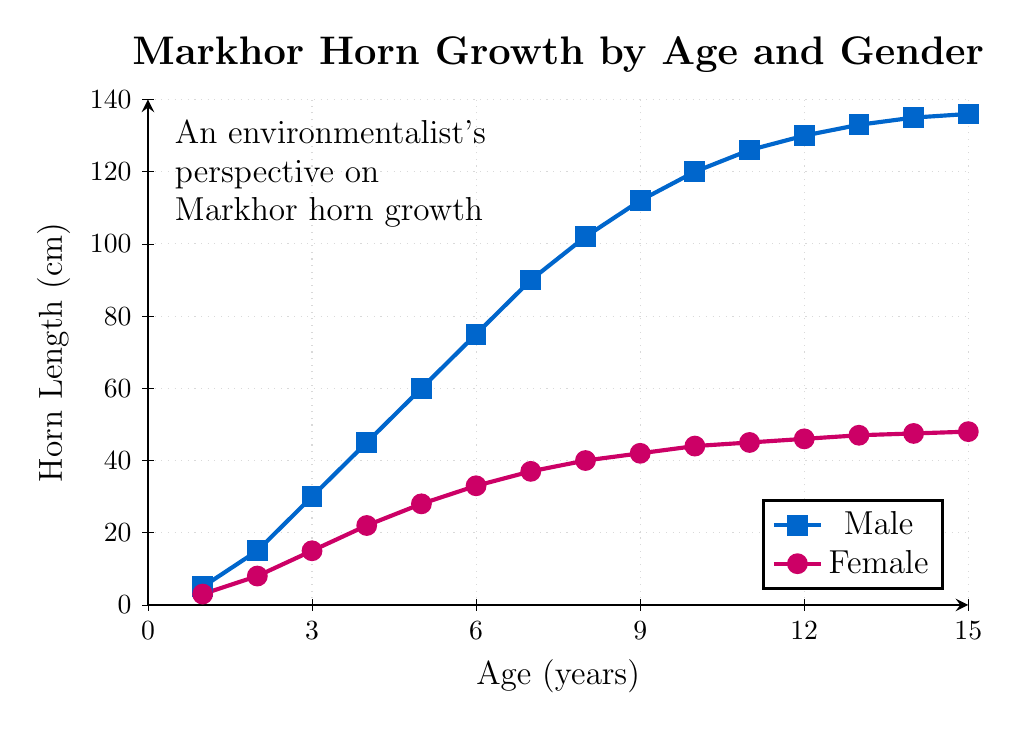What is the horn length difference between male and female Markhors at age 10? To find the difference in horn length between male and female Markhors at age 10, look at the horn lengths for both genders at that specific age. For males, it is 120 cm, and for females, it is 44 cm. Subtract the female length from the male length: 120 - 44 = 76 cm.
Answer: 76 cm At what age do male Markhor horns reach a length of over 100 cm? To determine the age at which male Markhor horns surpass 100 cm, look at the plotted horn lengths for males. The first age where the horn length exceeds 100 cm is at age 8 (102 cm).
Answer: Age 8 By how much do female Markhor horns grow between ages 1 and 5? Find the horn lengths for female Markhors at ages 1 and 5. At age 1, the horn length is 3 cm, and at age 5, it is 28 cm. Subtract the horn length at age 1 from the horn length at age 5: 28 - 3 = 25 cm.
Answer: 25 cm Is there a period where the growth rate of male horns significantly slows down? If so, when? Observe the slope (rate of change) of the male horn growth line. The growth rate significantly slows down around age 11 to 15. Before age 11, the horn length grows rapidly, but from age 11 (126 cm) to age 15 (136 cm), the growth is much slower.
Answer: Ages 11-15 Compare the horn lengths of female Markhors at ages 6 and 12. Which age shows a greater horn length and by how much? Look at the horn lengths for female Markhors at ages 6 and 12. At age 6, the horn length is 33 cm, and at age 12, it is 46 cm. Age 12 shows a greater horn length, and the difference is 46 - 33 = 13 cm.
Answer: Age 12 by 13 cm What is the average horn length for male Markhors between ages 7 and 10? To find the average horn length, add the horn lengths for male Markhors from ages 7 to 10 and divide by the number of values. The horn lengths are 90, 102, 112, and 120 cm. Sum these up: 90 + 102 + 112 + 120 = 424 cm. The number of values is 4. So, the average is 424 / 4 = 106 cm.
Answer: 106 cm Who has longer horns at age 15, male or female Markhors, and by how much? Check the horn lengths at age 15 for both genders. For males, it is 136 cm, and for females, it is 48 cm. Males have longer horns, and the difference is 136 - 48 = 88 cm.
Answer: Males by 88 cm What is the overall trend in horn growth for both male and female Markhors? Observe the overall direction and pattern of the lines. Both male and female horn lengths increase with age. Male horn length grows rapidly initially and starts to plateau after age 10. Female horn length increases steadily but at a slower rate compared to males.
Answer: Increasing trend with faster growth for males Which gender shows more variation in horn length growth, and what does this imply? Compare the smoothness and steepness of the lines for both genders. Males show a steeper and more variable growth, indicating faster and more varied horn length changes, while females show more steady and less variable growth.
Answer: Males show more variation At what ages do female Markhors' horn growth rate slow down? Look at the changes in the slope of the female growth line. The slope significantly decreases around ages 12 to 15. Before age 12, the growth rate is steady, but after age 12 (46 cm), it only grows slightly to 48 cm by age 15.
Answer: Ages 12-15 